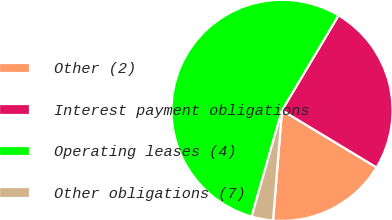<chart> <loc_0><loc_0><loc_500><loc_500><pie_chart><fcel>Other (2)<fcel>Interest payment obligations<fcel>Operating leases (4)<fcel>Other obligations (7)<nl><fcel>17.65%<fcel>25.1%<fcel>54.12%<fcel>3.14%<nl></chart> 